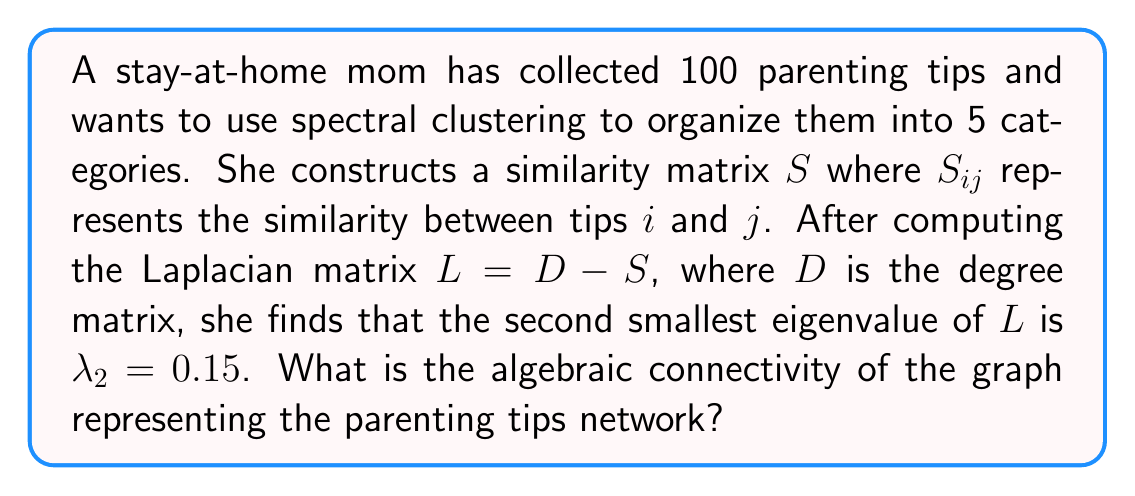Can you solve this math problem? To solve this problem, we need to understand the concept of algebraic connectivity in spectral graph theory:

1. The algebraic connectivity of a graph is defined as the second smallest eigenvalue of the Laplacian matrix $L$.

2. The Laplacian matrix $L$ is given by $L = D - S$, where:
   - $D$ is the degree matrix (a diagonal matrix where $D_{ii}$ is the sum of the $i$-th row of $S$)
   - $S$ is the similarity matrix

3. The eigenvalues of $L$ are typically ordered as:
   $$ 0 = \lambda_1 \leq \lambda_2 \leq \lambda_3 \leq ... \leq \lambda_n $$

4. In this case, we are given that $\lambda_2 = 0.15$.

5. By definition, the algebraic connectivity is equal to $\lambda_2$.

Therefore, the algebraic connectivity of the graph representing the parenting tips network is 0.15.
Answer: 0.15 